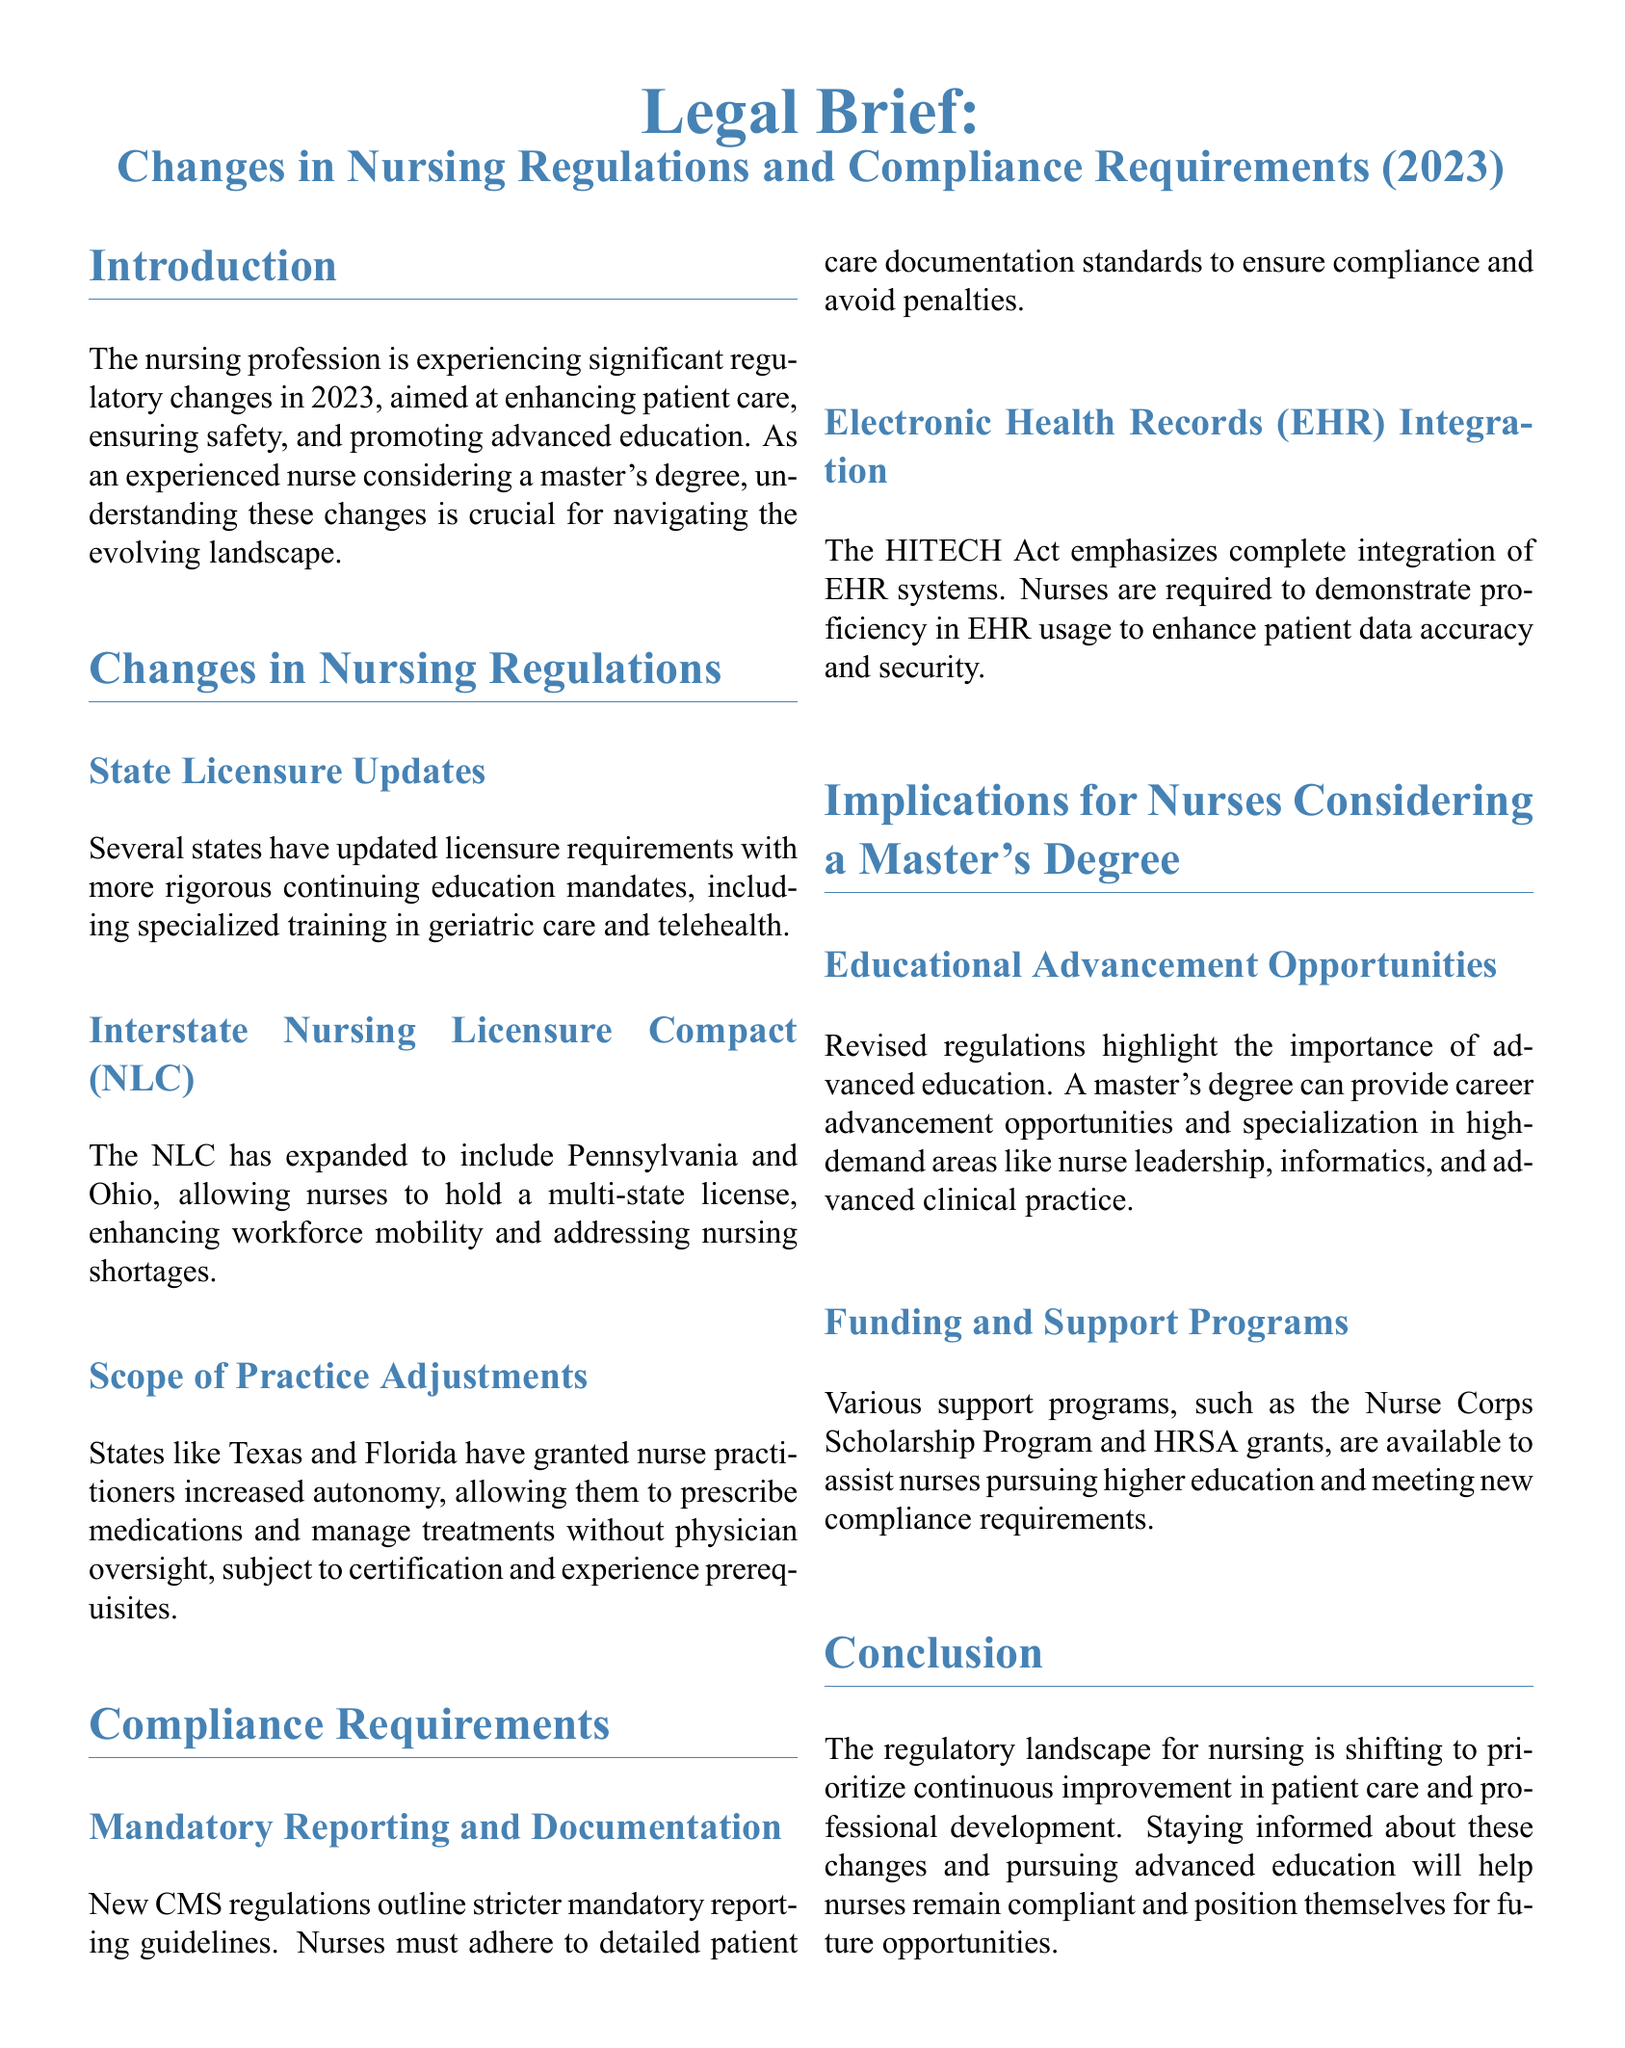What are the new licensure requirements focused on? The new licensure requirements focus on more rigorous continuing education mandates, including specialized training in geriatric care and telehealth.
Answer: Geriatric care and telehealth Which states joined the Interstate Nursing Licensure Compact in 2023? The document mentions that Pennsylvania and Ohio expanded the Interstate Nursing Licensure Compact.
Answer: Pennsylvania and Ohio What recent regulatory change enhances nurse practitioners' autonomy? States like Texas and Florida have granted nurse practitioners increased autonomy to prescribe medications and manage treatments without physician oversight.
Answer: Increased autonomy What does CMS stand for in the context of new compliance requirements? CMS refers to the Centers for Medicare and Medicaid Services, which outlines stricter mandatory reporting guidelines for nurses.
Answer: Centers for Medicare and Medicaid Services What is emphasized by the HITECH Act regarding EHR? The HITECH Act emphasizes the complete integration of Electronic Health Records (EHR) systems, requiring nurses to demonstrate proficiency in EHR usage.
Answer: Complete integration What educational advancement opportunities are highlighted in the document? The document highlights that revised regulations emphasize the importance of advanced education for career advancement and specialization.
Answer: Advanced education What support programs are mentioned for nurses pursuing higher education? The document mentions the Nurse Corps Scholarship Program and HRSA grants as support programs for nurses pursuing higher education.
Answer: Nurse Corps Scholarship Program and HRSA grants What is the main goal of the regulatory changes in nursing for 2023? The main goal of the regulatory changes is to prioritize continuous improvement in patient care and professional development.
Answer: Continuous improvement in patient care and professional development What type of document is this? This document is a legal brief focused on changes in nursing regulations and compliance requirements.
Answer: Legal brief 